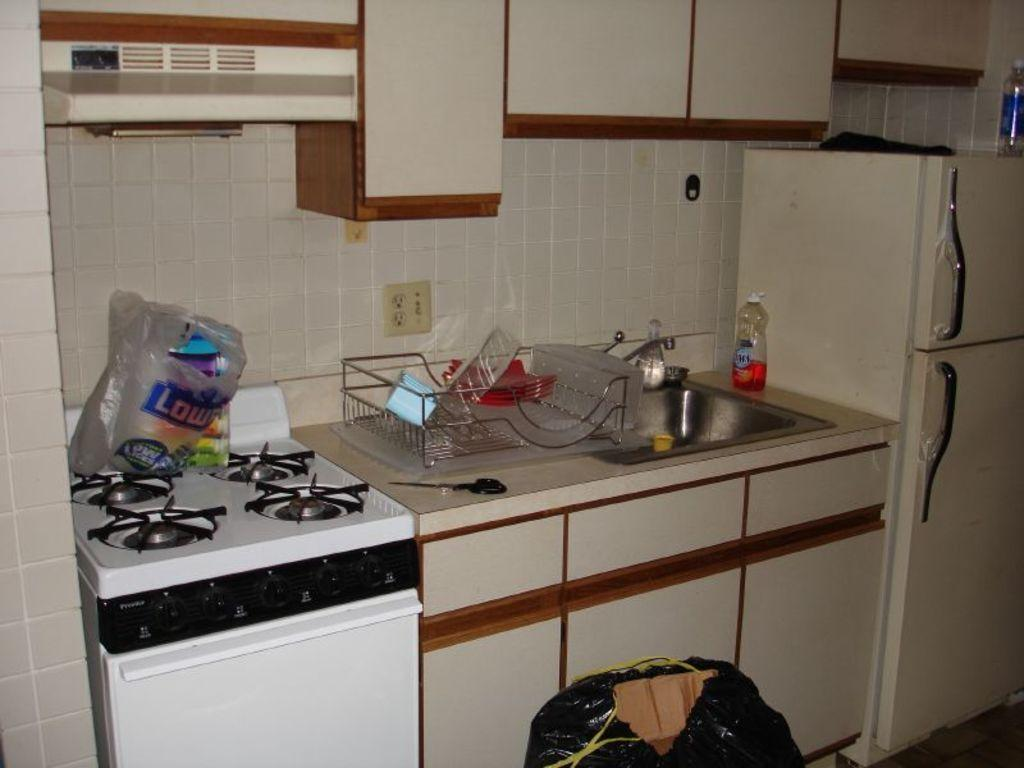What type of appliance can be seen in the image? There is a stove in the image. What type of storage furniture is present in the image? There are cupboards in the image. What type of protective covering is visible in the image? There is a plastic cover in the image. What type of container is present in the image? There is a mesh container in the image. What type of water fixture is present in the image? There is a tap in the image. What type of basin is present in the image? There is a wash basin in the image. What type of beverage container is present in the image? There is a bottle in the image. What type of appliance for preserving food is present in the image? There is a fridge in the image. What type of architectural feature is present in the image? There is a wall in the image. How many children are playing with pies in the image? There are no children or pies present in the image. Is it raining in the image? There is no indication of rain in the image. 